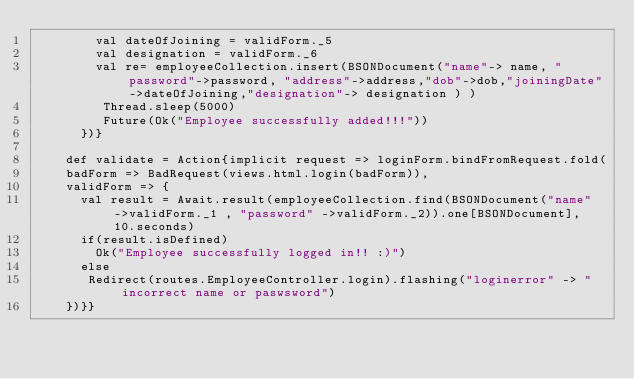Convert code to text. <code><loc_0><loc_0><loc_500><loc_500><_Scala_>        val dateOfJoining = validForm._5
        val designation = validForm._6
        val re= employeeCollection.insert(BSONDocument("name"-> name, "password"->password, "address"->address,"dob"->dob,"joiningDate"->dateOfJoining,"designation"-> designation ) )
         Thread.sleep(5000)
         Future(Ok("Employee successfully added!!!"))
      })}

    def validate = Action{implicit request => loginForm.bindFromRequest.fold(
    badForm => BadRequest(views.html.login(badForm)),
    validForm => {
      val result = Await.result(employeeCollection.find(BSONDocument("name" ->validForm._1 , "password" ->validForm._2)).one[BSONDocument], 10.seconds)
      if(result.isDefined)
        Ok("Employee successfully logged in!! :)")
      else
       Redirect(routes.EmployeeController.login).flashing("loginerror" -> "incorrect name or paswsword")
    })}}
</code> 